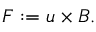Convert formula to latex. <formula><loc_0><loc_0><loc_500><loc_500>\begin{array} { r } { F \colon = u \times B . } \end{array}</formula> 